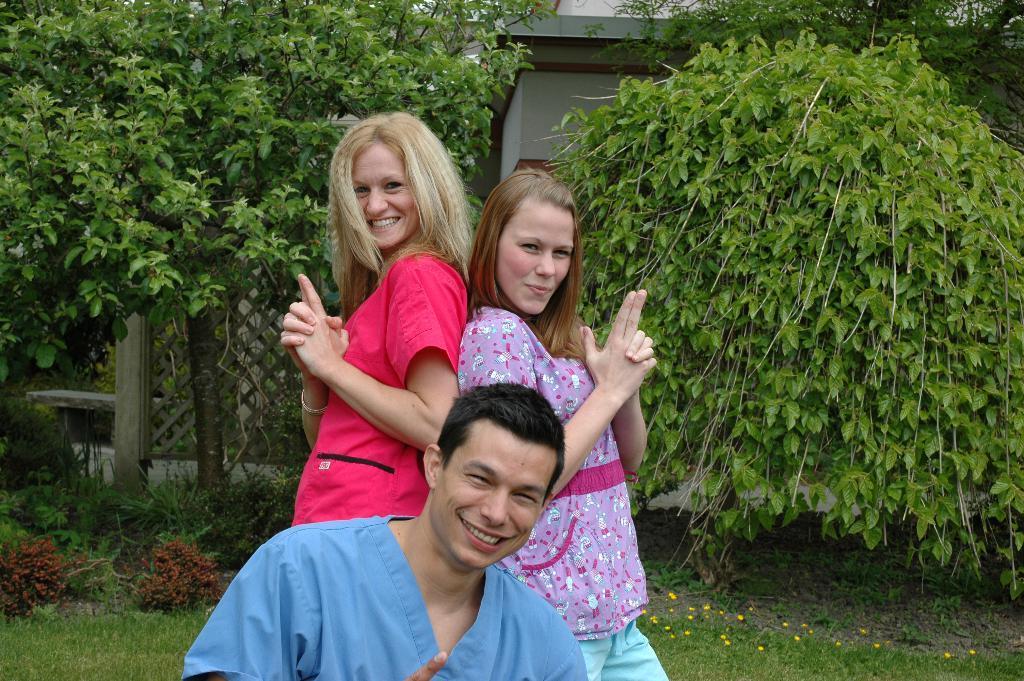How would you summarize this image in a sentence or two? In this image I see a man and 2 women and I see that all of them are smiling. In the background I see the green grass, plants and the trees and I see the fencing over here and I see the white wall. 